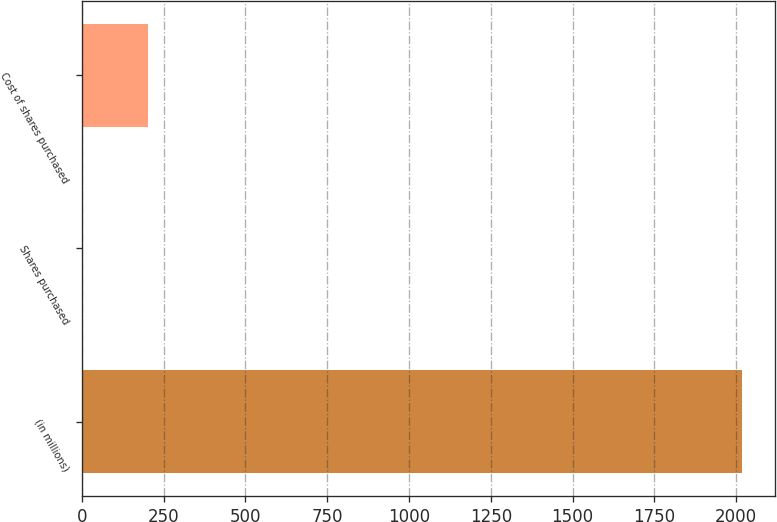<chart> <loc_0><loc_0><loc_500><loc_500><bar_chart><fcel>(in millions)<fcel>Shares purchased<fcel>Cost of shares purchased<nl><fcel>2018<fcel>1.1<fcel>202.79<nl></chart> 